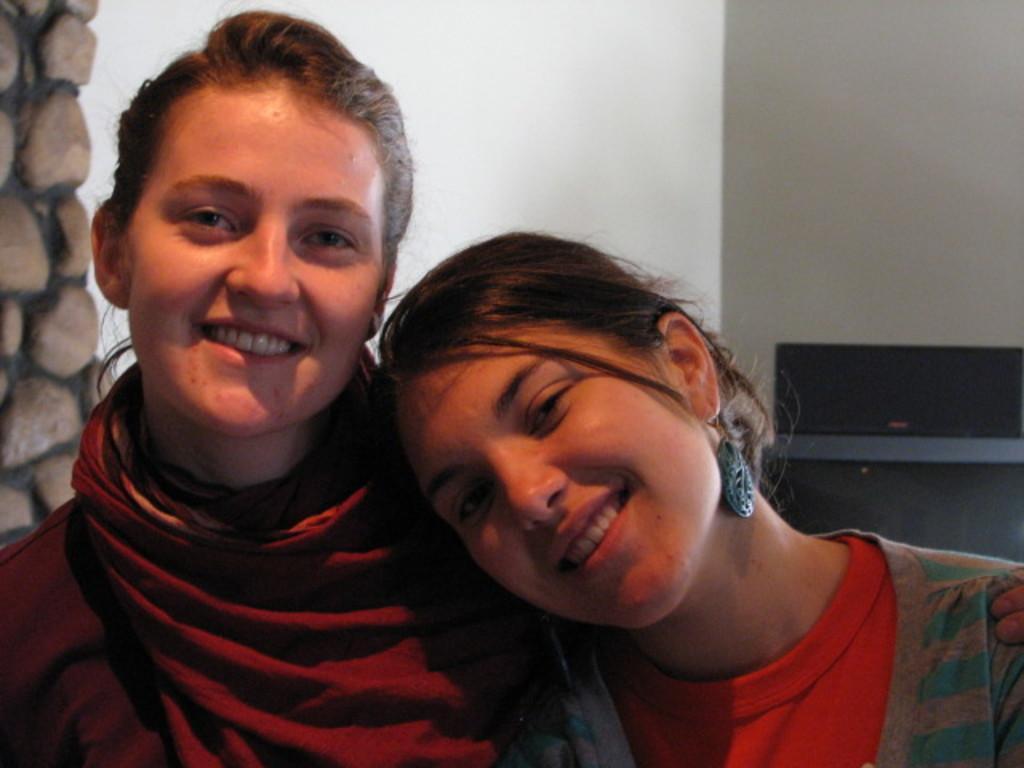Describe this image in one or two sentences. In this picture there are two girls sitting in the front , smiling and giving pose into the camera. Behind there is a white wall. On the left corner we can see the stone pillar. 